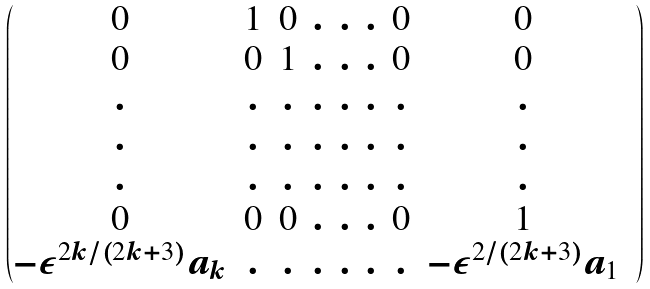<formula> <loc_0><loc_0><loc_500><loc_500>\begin{pmatrix} 0 & 1 & 0 & . & . & . & 0 & 0 & \\ 0 & 0 & 1 & . & . & . & 0 & 0 & \\ . & . & . & . & . & . & . & . & \\ . & . & . & . & . & . & . & . & \\ . & . & . & . & . & . & . & . & \\ 0 & 0 & 0 & . & . & . & 0 & 1 & \\ - \varepsilon ^ { 2 k / ( 2 k + 3 ) } a _ { k } & . & . & . & . & . & . & - \varepsilon ^ { 2 / ( 2 k + 3 ) } a _ { 1 } & \end{pmatrix}</formula> 